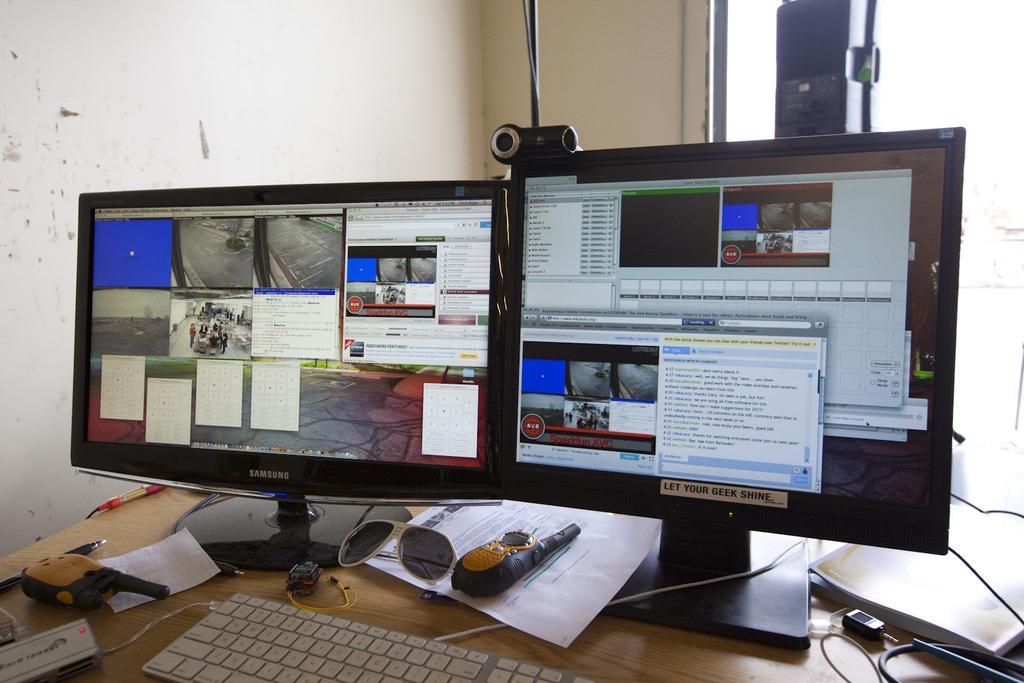Can you describe this image briefly? In this image I can see few monitors, keyboard, papers, wires and few objects on the table. I can see the wall. 